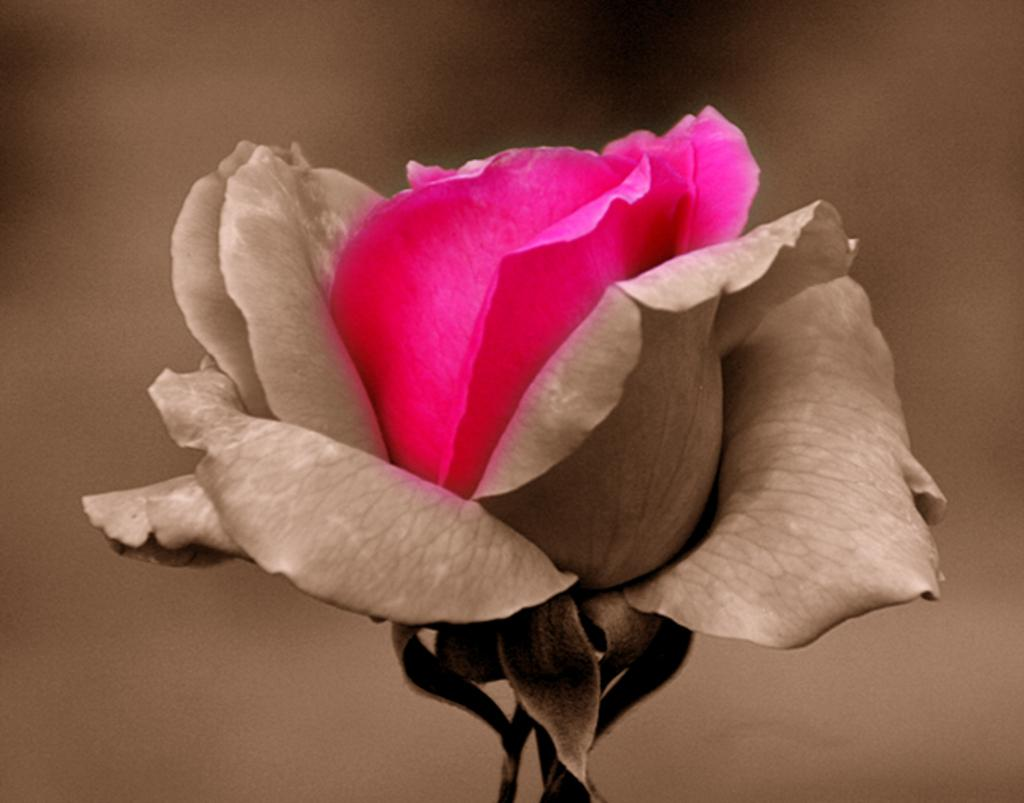What type of flower is in the picture? There is a rose in the picture. What color are the petals of the rose? The rose has partially pink petals. Can you tell if the image has been altered in any way? Yes, the image is an edited image. How much steam is coming off the rose in the image? There is no steam present in the image, as it features a rose with partially pink petals. What type of guide is shown assisting with the rose in the image? There is no guide present in the image; it only shows a rose with partially pink petals. 